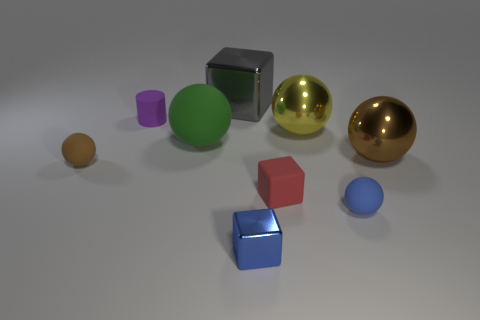Subtract all tiny balls. How many balls are left? 3 Add 1 big gray shiny objects. How many objects exist? 10 Subtract all yellow spheres. How many spheres are left? 4 Subtract all cubes. How many objects are left? 6 Subtract 1 cubes. How many cubes are left? 2 Add 4 large gray objects. How many large gray objects are left? 5 Add 1 small matte balls. How many small matte balls exist? 3 Subtract 0 purple balls. How many objects are left? 9 Subtract all green cylinders. Subtract all blue spheres. How many cylinders are left? 1 Subtract all red spheres. How many gray blocks are left? 1 